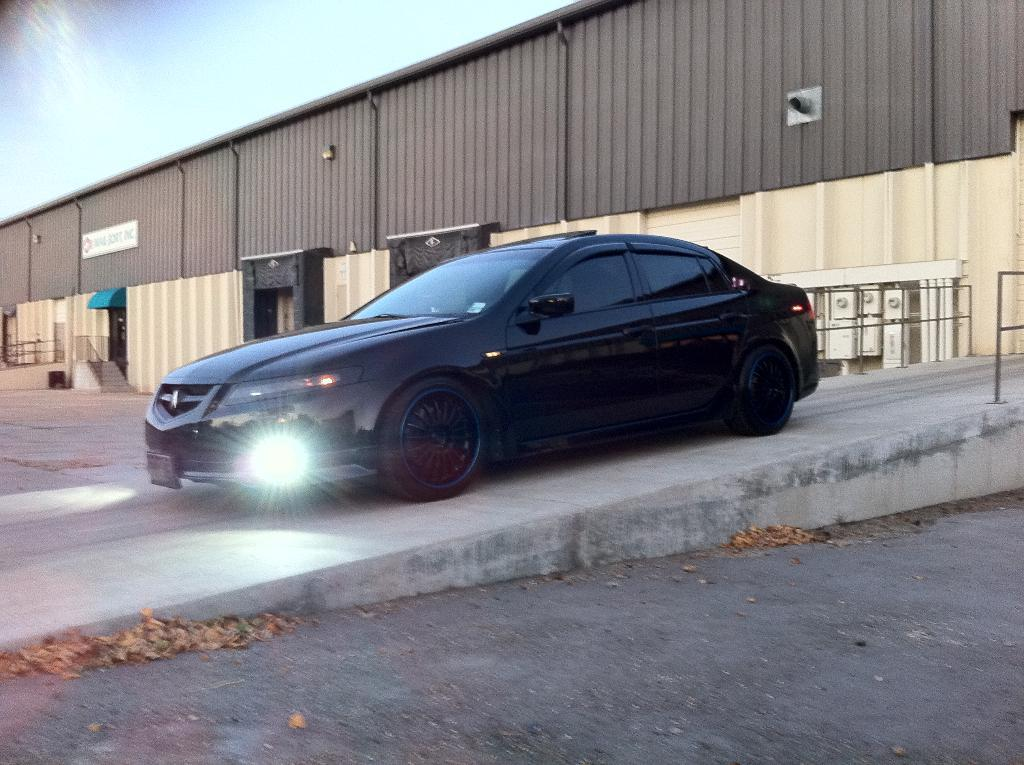What is the main subject of the image? There is a car in the center of the image. What color is the car? The car is black in color. What is the car doing in the image? The car is moving on a ramp. What can be seen in the background of the image? There is a tin shed in the background of the image. What is present on the ground in the front of the image? Dry leaves are present on the ground in the front of the image. Can you see any waves in the image? There are no waves present in the image; it features a car moving on a ramp with a tin shed in the background and dry leaves on the ground in the front. 